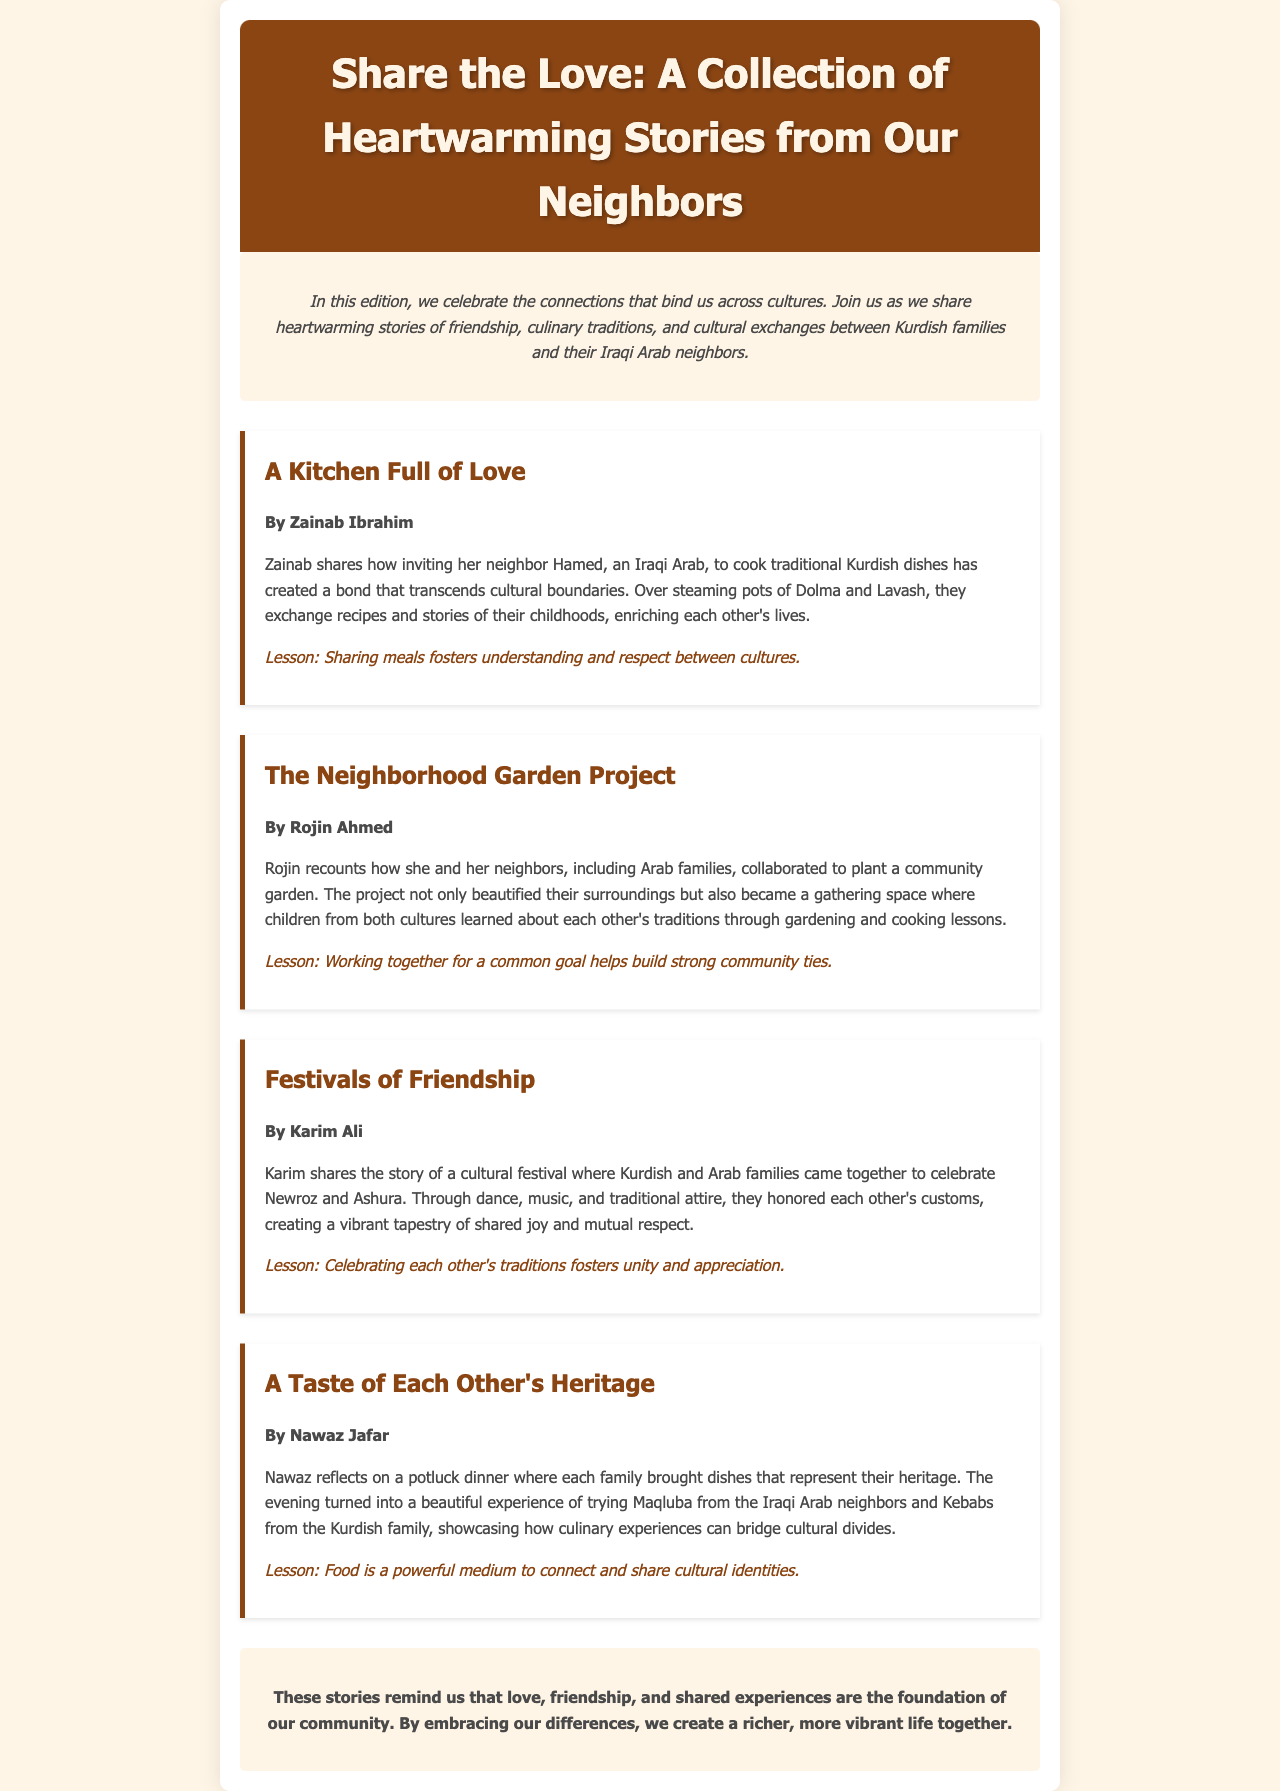What is the title of the newsletter? The title is presented in the header section of the document.
Answer: Share the Love: A Collection of Heartwarming Stories from Our Neighbors Who wrote the story about cooking traditional Kurdish dishes? The author's name is mentioned below the title of the story in the document.
Answer: Zainab Ibrahim What community project did Rojin Ahmed discuss? The project is described in the second story, highlighting a collaborative effort.
Answer: Neighborhood Garden Project Which festival is mentioned in Karim Ali's story? The festival is emphasized as a cultural event that brings families together.
Answer: Newroz and Ashura What does Nawaz Jafar reflect on in his story? His reflection focuses on an event that showcases cultural sharing through food.
Answer: A potluck dinner What is one lesson from Zainab's story? The lesson is drawn from the experiences shared in the story.
Answer: Sharing meals fosters understanding and respect between cultures How do the stories contribute to the community? The concluding remarks summarize the overall impact of the stories.
Answer: Love, friendship, and shared experiences What type of meals are highlighted in the stories? The meals discussed reflect on cultural identities and experiences of the families.
Answer: Traditional dishes 